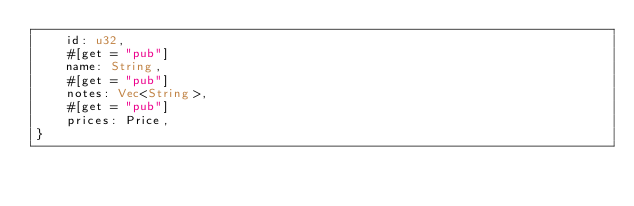<code> <loc_0><loc_0><loc_500><loc_500><_Rust_>    id: u32,
    #[get = "pub"]
    name: String,
    #[get = "pub"]
    notes: Vec<String>,
    #[get = "pub"]
    prices: Price,
}
</code> 